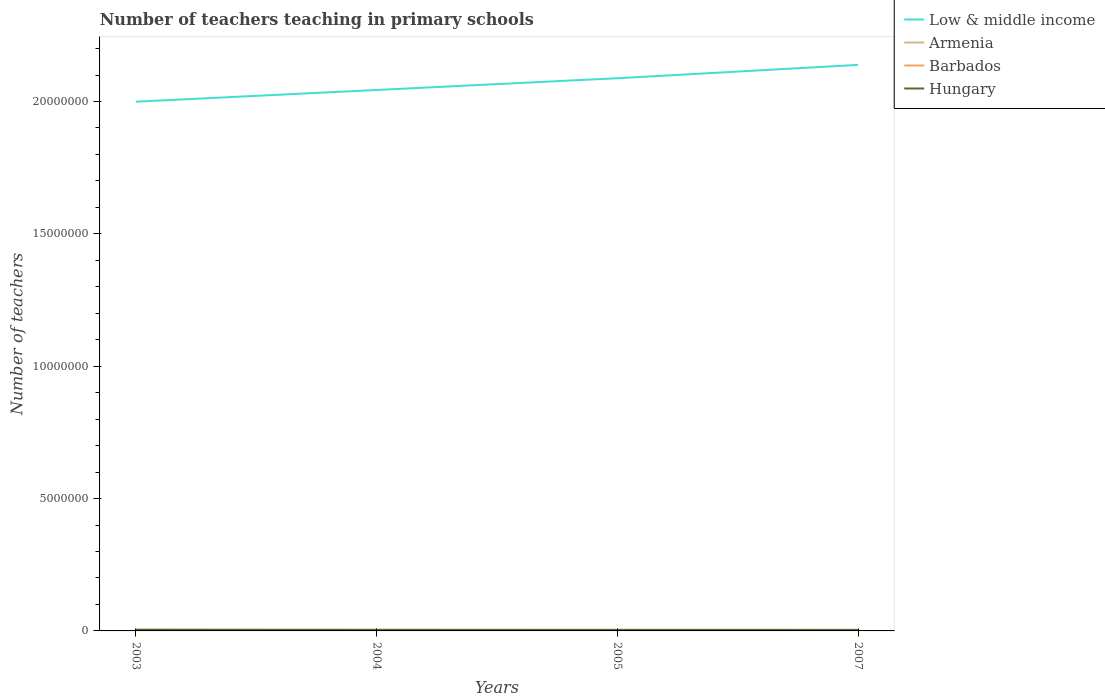How many different coloured lines are there?
Your answer should be compact. 4. Across all years, what is the maximum number of teachers teaching in primary schools in Low & middle income?
Your answer should be very brief. 2.00e+07. What is the total number of teachers teaching in primary schools in Barbados in the graph?
Your answer should be compact. -84. What is the difference between the highest and the second highest number of teachers teaching in primary schools in Armenia?
Ensure brevity in your answer.  1731. How many lines are there?
Give a very brief answer. 4. How many years are there in the graph?
Keep it short and to the point. 4. What is the difference between two consecutive major ticks on the Y-axis?
Give a very brief answer. 5.00e+06. Does the graph contain grids?
Make the answer very short. No. Where does the legend appear in the graph?
Ensure brevity in your answer.  Top right. How are the legend labels stacked?
Your answer should be compact. Vertical. What is the title of the graph?
Offer a terse response. Number of teachers teaching in primary schools. Does "Iraq" appear as one of the legend labels in the graph?
Your answer should be very brief. No. What is the label or title of the Y-axis?
Provide a short and direct response. Number of teachers. What is the Number of teachers of Low & middle income in 2003?
Offer a very short reply. 2.00e+07. What is the Number of teachers of Armenia in 2003?
Provide a short and direct response. 7635. What is the Number of teachers in Barbados in 2003?
Your answer should be very brief. 1460. What is the Number of teachers in Hungary in 2003?
Keep it short and to the point. 4.84e+04. What is the Number of teachers in Low & middle income in 2004?
Ensure brevity in your answer.  2.04e+07. What is the Number of teachers in Armenia in 2004?
Your response must be concise. 6646. What is the Number of teachers in Barbados in 2004?
Offer a very short reply. 1416. What is the Number of teachers of Hungary in 2004?
Offer a terse response. 4.26e+04. What is the Number of teachers in Low & middle income in 2005?
Your answer should be compact. 2.09e+07. What is the Number of teachers in Armenia in 2005?
Keep it short and to the point. 5904. What is the Number of teachers in Barbados in 2005?
Provide a short and direct response. 1469. What is the Number of teachers in Hungary in 2005?
Keep it short and to the point. 4.12e+04. What is the Number of teachers in Low & middle income in 2007?
Keep it short and to the point. 2.14e+07. What is the Number of teachers in Armenia in 2007?
Provide a succinct answer. 6606. What is the Number of teachers in Barbados in 2007?
Make the answer very short. 1553. What is the Number of teachers in Hungary in 2007?
Provide a succinct answer. 3.97e+04. Across all years, what is the maximum Number of teachers of Low & middle income?
Provide a short and direct response. 2.14e+07. Across all years, what is the maximum Number of teachers in Armenia?
Your response must be concise. 7635. Across all years, what is the maximum Number of teachers of Barbados?
Ensure brevity in your answer.  1553. Across all years, what is the maximum Number of teachers of Hungary?
Your response must be concise. 4.84e+04. Across all years, what is the minimum Number of teachers in Low & middle income?
Provide a succinct answer. 2.00e+07. Across all years, what is the minimum Number of teachers of Armenia?
Ensure brevity in your answer.  5904. Across all years, what is the minimum Number of teachers of Barbados?
Give a very brief answer. 1416. Across all years, what is the minimum Number of teachers in Hungary?
Make the answer very short. 3.97e+04. What is the total Number of teachers of Low & middle income in the graph?
Make the answer very short. 8.27e+07. What is the total Number of teachers in Armenia in the graph?
Ensure brevity in your answer.  2.68e+04. What is the total Number of teachers of Barbados in the graph?
Your answer should be very brief. 5898. What is the total Number of teachers of Hungary in the graph?
Make the answer very short. 1.72e+05. What is the difference between the Number of teachers of Low & middle income in 2003 and that in 2004?
Make the answer very short. -4.43e+05. What is the difference between the Number of teachers of Armenia in 2003 and that in 2004?
Provide a succinct answer. 989. What is the difference between the Number of teachers of Barbados in 2003 and that in 2004?
Give a very brief answer. 44. What is the difference between the Number of teachers in Hungary in 2003 and that in 2004?
Give a very brief answer. 5750. What is the difference between the Number of teachers in Low & middle income in 2003 and that in 2005?
Offer a terse response. -8.86e+05. What is the difference between the Number of teachers in Armenia in 2003 and that in 2005?
Make the answer very short. 1731. What is the difference between the Number of teachers of Hungary in 2003 and that in 2005?
Give a very brief answer. 7163. What is the difference between the Number of teachers in Low & middle income in 2003 and that in 2007?
Your answer should be compact. -1.39e+06. What is the difference between the Number of teachers in Armenia in 2003 and that in 2007?
Keep it short and to the point. 1029. What is the difference between the Number of teachers of Barbados in 2003 and that in 2007?
Your answer should be very brief. -93. What is the difference between the Number of teachers of Hungary in 2003 and that in 2007?
Your response must be concise. 8687. What is the difference between the Number of teachers of Low & middle income in 2004 and that in 2005?
Your answer should be compact. -4.43e+05. What is the difference between the Number of teachers in Armenia in 2004 and that in 2005?
Your response must be concise. 742. What is the difference between the Number of teachers in Barbados in 2004 and that in 2005?
Your answer should be compact. -53. What is the difference between the Number of teachers in Hungary in 2004 and that in 2005?
Offer a terse response. 1413. What is the difference between the Number of teachers of Low & middle income in 2004 and that in 2007?
Your answer should be compact. -9.48e+05. What is the difference between the Number of teachers in Barbados in 2004 and that in 2007?
Make the answer very short. -137. What is the difference between the Number of teachers in Hungary in 2004 and that in 2007?
Make the answer very short. 2937. What is the difference between the Number of teachers of Low & middle income in 2005 and that in 2007?
Provide a succinct answer. -5.05e+05. What is the difference between the Number of teachers of Armenia in 2005 and that in 2007?
Give a very brief answer. -702. What is the difference between the Number of teachers of Barbados in 2005 and that in 2007?
Make the answer very short. -84. What is the difference between the Number of teachers in Hungary in 2005 and that in 2007?
Keep it short and to the point. 1524. What is the difference between the Number of teachers of Low & middle income in 2003 and the Number of teachers of Armenia in 2004?
Provide a succinct answer. 2.00e+07. What is the difference between the Number of teachers of Low & middle income in 2003 and the Number of teachers of Barbados in 2004?
Provide a succinct answer. 2.00e+07. What is the difference between the Number of teachers of Low & middle income in 2003 and the Number of teachers of Hungary in 2004?
Your answer should be very brief. 1.99e+07. What is the difference between the Number of teachers of Armenia in 2003 and the Number of teachers of Barbados in 2004?
Your answer should be compact. 6219. What is the difference between the Number of teachers of Armenia in 2003 and the Number of teachers of Hungary in 2004?
Your response must be concise. -3.50e+04. What is the difference between the Number of teachers in Barbados in 2003 and the Number of teachers in Hungary in 2004?
Make the answer very short. -4.12e+04. What is the difference between the Number of teachers in Low & middle income in 2003 and the Number of teachers in Armenia in 2005?
Your answer should be very brief. 2.00e+07. What is the difference between the Number of teachers of Low & middle income in 2003 and the Number of teachers of Barbados in 2005?
Your response must be concise. 2.00e+07. What is the difference between the Number of teachers in Low & middle income in 2003 and the Number of teachers in Hungary in 2005?
Your response must be concise. 2.00e+07. What is the difference between the Number of teachers of Armenia in 2003 and the Number of teachers of Barbados in 2005?
Make the answer very short. 6166. What is the difference between the Number of teachers in Armenia in 2003 and the Number of teachers in Hungary in 2005?
Make the answer very short. -3.36e+04. What is the difference between the Number of teachers of Barbados in 2003 and the Number of teachers of Hungary in 2005?
Your answer should be compact. -3.98e+04. What is the difference between the Number of teachers of Low & middle income in 2003 and the Number of teachers of Armenia in 2007?
Offer a terse response. 2.00e+07. What is the difference between the Number of teachers of Low & middle income in 2003 and the Number of teachers of Barbados in 2007?
Provide a short and direct response. 2.00e+07. What is the difference between the Number of teachers of Low & middle income in 2003 and the Number of teachers of Hungary in 2007?
Offer a terse response. 2.00e+07. What is the difference between the Number of teachers of Armenia in 2003 and the Number of teachers of Barbados in 2007?
Make the answer very short. 6082. What is the difference between the Number of teachers in Armenia in 2003 and the Number of teachers in Hungary in 2007?
Make the answer very short. -3.21e+04. What is the difference between the Number of teachers of Barbados in 2003 and the Number of teachers of Hungary in 2007?
Offer a terse response. -3.82e+04. What is the difference between the Number of teachers of Low & middle income in 2004 and the Number of teachers of Armenia in 2005?
Provide a short and direct response. 2.04e+07. What is the difference between the Number of teachers in Low & middle income in 2004 and the Number of teachers in Barbados in 2005?
Offer a terse response. 2.04e+07. What is the difference between the Number of teachers of Low & middle income in 2004 and the Number of teachers of Hungary in 2005?
Your response must be concise. 2.04e+07. What is the difference between the Number of teachers of Armenia in 2004 and the Number of teachers of Barbados in 2005?
Offer a terse response. 5177. What is the difference between the Number of teachers of Armenia in 2004 and the Number of teachers of Hungary in 2005?
Make the answer very short. -3.46e+04. What is the difference between the Number of teachers of Barbados in 2004 and the Number of teachers of Hungary in 2005?
Offer a very short reply. -3.98e+04. What is the difference between the Number of teachers of Low & middle income in 2004 and the Number of teachers of Armenia in 2007?
Offer a terse response. 2.04e+07. What is the difference between the Number of teachers of Low & middle income in 2004 and the Number of teachers of Barbados in 2007?
Make the answer very short. 2.04e+07. What is the difference between the Number of teachers of Low & middle income in 2004 and the Number of teachers of Hungary in 2007?
Give a very brief answer. 2.04e+07. What is the difference between the Number of teachers of Armenia in 2004 and the Number of teachers of Barbados in 2007?
Offer a very short reply. 5093. What is the difference between the Number of teachers of Armenia in 2004 and the Number of teachers of Hungary in 2007?
Your answer should be very brief. -3.31e+04. What is the difference between the Number of teachers of Barbados in 2004 and the Number of teachers of Hungary in 2007?
Ensure brevity in your answer.  -3.83e+04. What is the difference between the Number of teachers of Low & middle income in 2005 and the Number of teachers of Armenia in 2007?
Offer a very short reply. 2.09e+07. What is the difference between the Number of teachers of Low & middle income in 2005 and the Number of teachers of Barbados in 2007?
Give a very brief answer. 2.09e+07. What is the difference between the Number of teachers of Low & middle income in 2005 and the Number of teachers of Hungary in 2007?
Your response must be concise. 2.08e+07. What is the difference between the Number of teachers of Armenia in 2005 and the Number of teachers of Barbados in 2007?
Your answer should be compact. 4351. What is the difference between the Number of teachers of Armenia in 2005 and the Number of teachers of Hungary in 2007?
Provide a succinct answer. -3.38e+04. What is the difference between the Number of teachers in Barbados in 2005 and the Number of teachers in Hungary in 2007?
Your answer should be very brief. -3.82e+04. What is the average Number of teachers in Low & middle income per year?
Make the answer very short. 2.07e+07. What is the average Number of teachers of Armenia per year?
Offer a terse response. 6697.75. What is the average Number of teachers in Barbados per year?
Give a very brief answer. 1474.5. What is the average Number of teachers in Hungary per year?
Your answer should be very brief. 4.30e+04. In the year 2003, what is the difference between the Number of teachers of Low & middle income and Number of teachers of Armenia?
Ensure brevity in your answer.  2.00e+07. In the year 2003, what is the difference between the Number of teachers in Low & middle income and Number of teachers in Barbados?
Offer a terse response. 2.00e+07. In the year 2003, what is the difference between the Number of teachers of Low & middle income and Number of teachers of Hungary?
Provide a short and direct response. 1.99e+07. In the year 2003, what is the difference between the Number of teachers in Armenia and Number of teachers in Barbados?
Provide a succinct answer. 6175. In the year 2003, what is the difference between the Number of teachers of Armenia and Number of teachers of Hungary?
Offer a terse response. -4.08e+04. In the year 2003, what is the difference between the Number of teachers of Barbados and Number of teachers of Hungary?
Your response must be concise. -4.69e+04. In the year 2004, what is the difference between the Number of teachers of Low & middle income and Number of teachers of Armenia?
Offer a terse response. 2.04e+07. In the year 2004, what is the difference between the Number of teachers in Low & middle income and Number of teachers in Barbados?
Provide a short and direct response. 2.04e+07. In the year 2004, what is the difference between the Number of teachers in Low & middle income and Number of teachers in Hungary?
Keep it short and to the point. 2.04e+07. In the year 2004, what is the difference between the Number of teachers in Armenia and Number of teachers in Barbados?
Ensure brevity in your answer.  5230. In the year 2004, what is the difference between the Number of teachers in Armenia and Number of teachers in Hungary?
Keep it short and to the point. -3.60e+04. In the year 2004, what is the difference between the Number of teachers in Barbados and Number of teachers in Hungary?
Keep it short and to the point. -4.12e+04. In the year 2005, what is the difference between the Number of teachers of Low & middle income and Number of teachers of Armenia?
Your response must be concise. 2.09e+07. In the year 2005, what is the difference between the Number of teachers of Low & middle income and Number of teachers of Barbados?
Your answer should be compact. 2.09e+07. In the year 2005, what is the difference between the Number of teachers of Low & middle income and Number of teachers of Hungary?
Ensure brevity in your answer.  2.08e+07. In the year 2005, what is the difference between the Number of teachers of Armenia and Number of teachers of Barbados?
Provide a short and direct response. 4435. In the year 2005, what is the difference between the Number of teachers in Armenia and Number of teachers in Hungary?
Ensure brevity in your answer.  -3.53e+04. In the year 2005, what is the difference between the Number of teachers in Barbados and Number of teachers in Hungary?
Offer a terse response. -3.98e+04. In the year 2007, what is the difference between the Number of teachers in Low & middle income and Number of teachers in Armenia?
Your answer should be compact. 2.14e+07. In the year 2007, what is the difference between the Number of teachers of Low & middle income and Number of teachers of Barbados?
Your response must be concise. 2.14e+07. In the year 2007, what is the difference between the Number of teachers of Low & middle income and Number of teachers of Hungary?
Ensure brevity in your answer.  2.13e+07. In the year 2007, what is the difference between the Number of teachers of Armenia and Number of teachers of Barbados?
Your answer should be compact. 5053. In the year 2007, what is the difference between the Number of teachers of Armenia and Number of teachers of Hungary?
Make the answer very short. -3.31e+04. In the year 2007, what is the difference between the Number of teachers in Barbados and Number of teachers in Hungary?
Your answer should be compact. -3.82e+04. What is the ratio of the Number of teachers of Low & middle income in 2003 to that in 2004?
Offer a terse response. 0.98. What is the ratio of the Number of teachers in Armenia in 2003 to that in 2004?
Provide a succinct answer. 1.15. What is the ratio of the Number of teachers in Barbados in 2003 to that in 2004?
Offer a very short reply. 1.03. What is the ratio of the Number of teachers of Hungary in 2003 to that in 2004?
Keep it short and to the point. 1.13. What is the ratio of the Number of teachers of Low & middle income in 2003 to that in 2005?
Your answer should be compact. 0.96. What is the ratio of the Number of teachers in Armenia in 2003 to that in 2005?
Your answer should be very brief. 1.29. What is the ratio of the Number of teachers of Hungary in 2003 to that in 2005?
Your response must be concise. 1.17. What is the ratio of the Number of teachers of Low & middle income in 2003 to that in 2007?
Make the answer very short. 0.94. What is the ratio of the Number of teachers of Armenia in 2003 to that in 2007?
Provide a succinct answer. 1.16. What is the ratio of the Number of teachers in Barbados in 2003 to that in 2007?
Ensure brevity in your answer.  0.94. What is the ratio of the Number of teachers in Hungary in 2003 to that in 2007?
Provide a succinct answer. 1.22. What is the ratio of the Number of teachers of Low & middle income in 2004 to that in 2005?
Give a very brief answer. 0.98. What is the ratio of the Number of teachers in Armenia in 2004 to that in 2005?
Ensure brevity in your answer.  1.13. What is the ratio of the Number of teachers of Barbados in 2004 to that in 2005?
Provide a succinct answer. 0.96. What is the ratio of the Number of teachers of Hungary in 2004 to that in 2005?
Make the answer very short. 1.03. What is the ratio of the Number of teachers in Low & middle income in 2004 to that in 2007?
Offer a terse response. 0.96. What is the ratio of the Number of teachers in Armenia in 2004 to that in 2007?
Your answer should be compact. 1.01. What is the ratio of the Number of teachers in Barbados in 2004 to that in 2007?
Give a very brief answer. 0.91. What is the ratio of the Number of teachers in Hungary in 2004 to that in 2007?
Ensure brevity in your answer.  1.07. What is the ratio of the Number of teachers of Low & middle income in 2005 to that in 2007?
Provide a short and direct response. 0.98. What is the ratio of the Number of teachers in Armenia in 2005 to that in 2007?
Give a very brief answer. 0.89. What is the ratio of the Number of teachers in Barbados in 2005 to that in 2007?
Keep it short and to the point. 0.95. What is the ratio of the Number of teachers in Hungary in 2005 to that in 2007?
Offer a terse response. 1.04. What is the difference between the highest and the second highest Number of teachers in Low & middle income?
Your answer should be very brief. 5.05e+05. What is the difference between the highest and the second highest Number of teachers of Armenia?
Make the answer very short. 989. What is the difference between the highest and the second highest Number of teachers in Hungary?
Provide a succinct answer. 5750. What is the difference between the highest and the lowest Number of teachers of Low & middle income?
Provide a succinct answer. 1.39e+06. What is the difference between the highest and the lowest Number of teachers in Armenia?
Keep it short and to the point. 1731. What is the difference between the highest and the lowest Number of teachers of Barbados?
Your response must be concise. 137. What is the difference between the highest and the lowest Number of teachers of Hungary?
Your answer should be compact. 8687. 